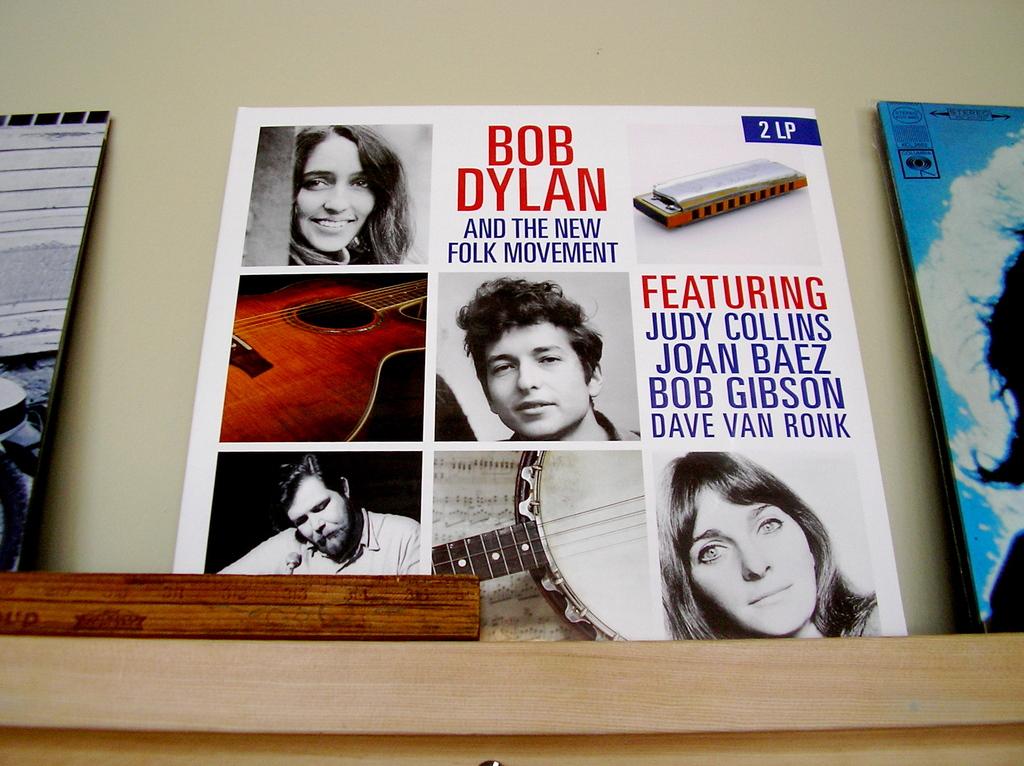Who else is on this besides bob dylan?
Offer a very short reply. Judy collins. What is the number before lo on the blue box?
Provide a short and direct response. 2. 